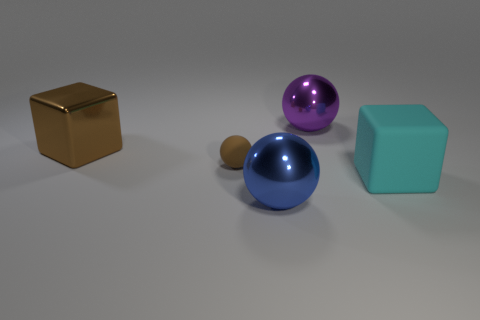Subtract all purple metallic spheres. How many spheres are left? 2 Add 2 blue objects. How many objects exist? 7 Subtract all blocks. How many objects are left? 3 Subtract 0 gray blocks. How many objects are left? 5 Subtract all spheres. Subtract all small objects. How many objects are left? 1 Add 2 tiny brown things. How many tiny brown things are left? 3 Add 5 large matte balls. How many large matte balls exist? 5 